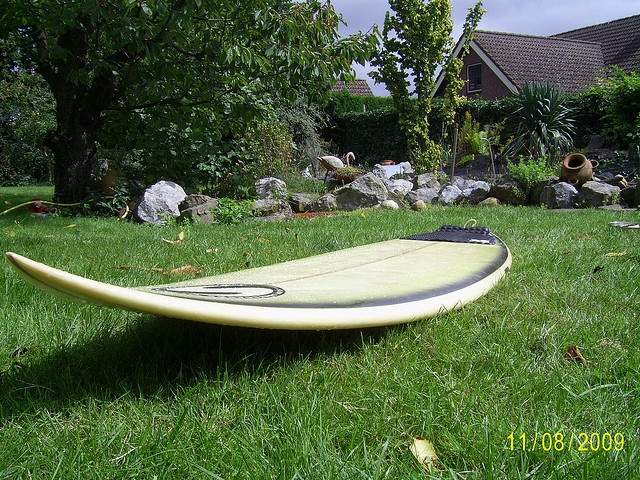Describe the objects in this image and their specific colors. I can see surfboard in black, beige, darkgreen, and darkgray tones and bird in black, gray, darkgray, and lightgray tones in this image. 